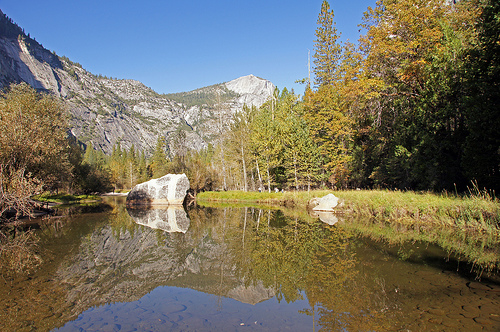<image>
Is the rock on the land? Yes. Looking at the image, I can see the rock is positioned on top of the land, with the land providing support. 